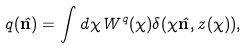<formula> <loc_0><loc_0><loc_500><loc_500>q ( \hat { \mathbf n } ) = \int d \chi W ^ { q } ( \chi ) \delta ( \chi { \hat { \mathbf n } } , z ( \chi ) ) ,</formula> 